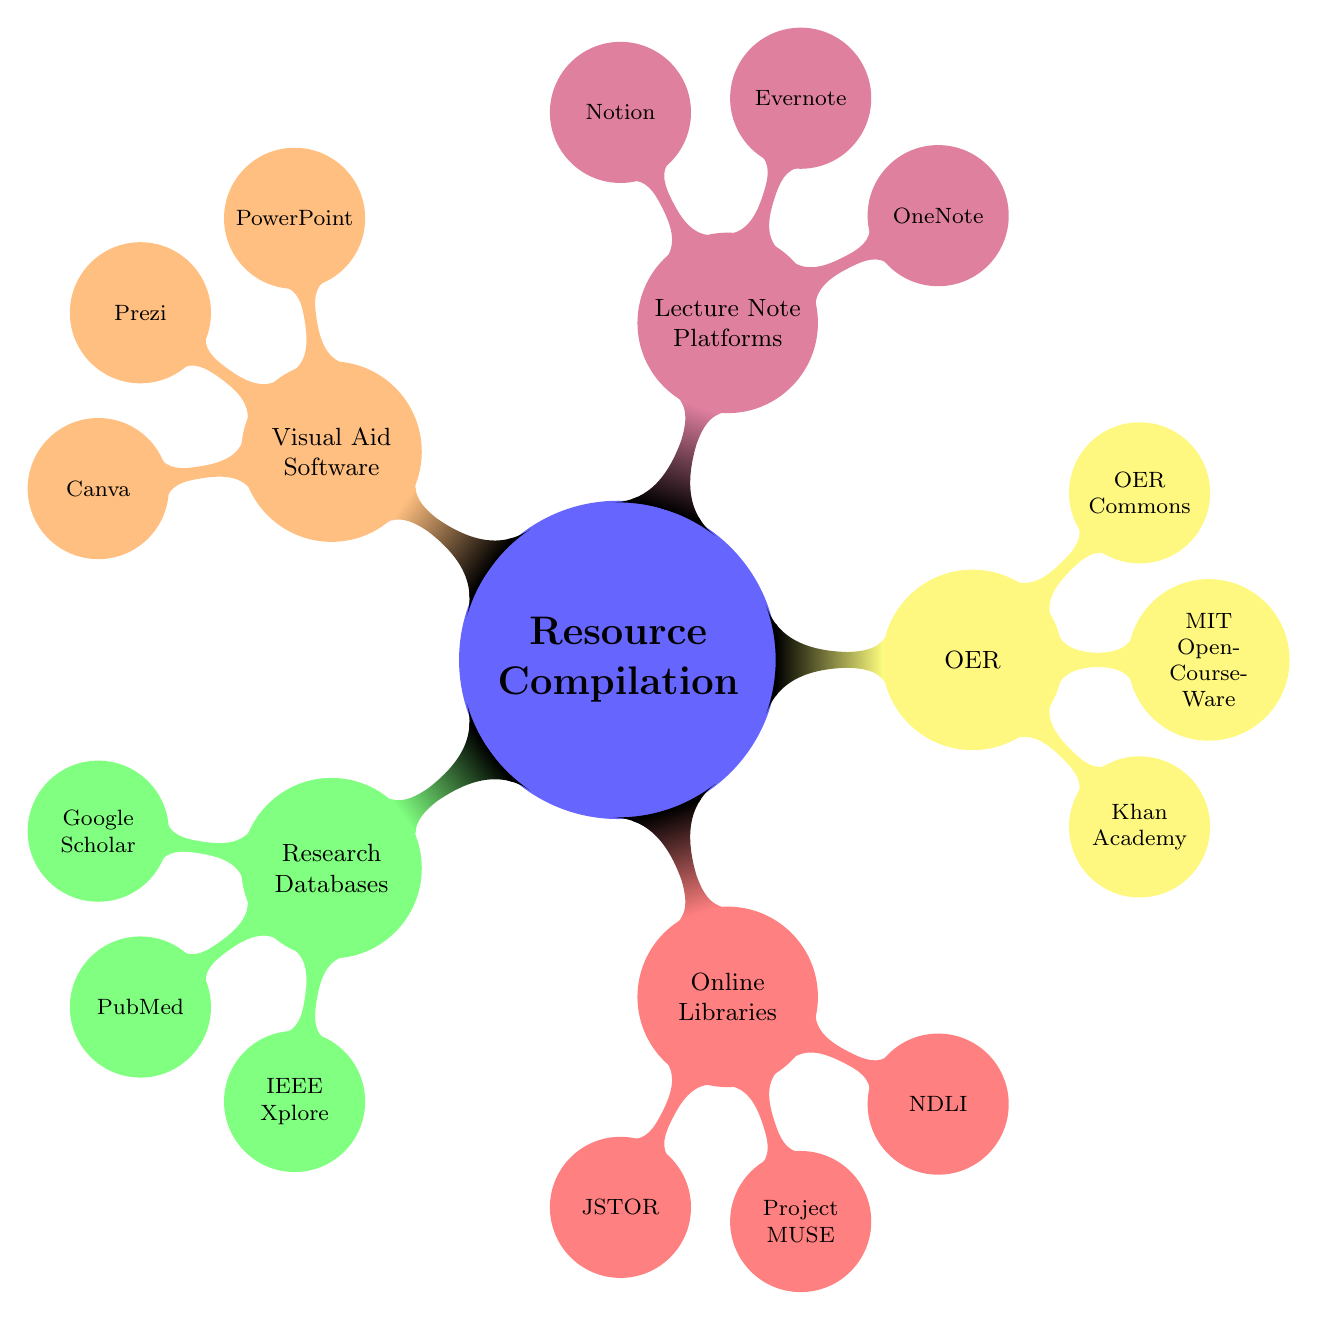What is a resource listed under Research Databases? The question prompts for a specific resource belonging to the "Research Databases" category. Looking at the diagram, the options include Google Scholar, PubMed, and IEEE Xplore. Any of these would be correct.
Answer: Google Scholar How many main categories are there in the mind map? The main categories branch from the central node labeled "Resource Compilation." These categories are "Research Databases," "Online Libraries," "Open Educational Resources," "Lecture Note Platforms," and "Visual Aid Software." Counting those gives us a total of five categories.
Answer: 5 Which platform is known for providing comprehensive educational videos? This question asks for a specific platform associated with educational content in the "Open Educational Resources" section. By examining the nodes under that category, Khan Academy is clearly indicated as providing comprehensive educational videos.
Answer: Khan Academy What type of software is PowerPoint categorized under? The question focuses on the category of "PowerPoint." According to the structure of the mind map, PowerPoint falls under the "Visual Aid Software" category. This connection can be made by noting where PowerPoint is situated in relation to other nodes.
Answer: Visual Aid Software How many resources are listed under Online Libraries? To answer this question, we look into the "Online Libraries" category and count the connected nodes: JSTOR, Project MUSE, and National Digital Library of India, which totals three resources.
Answer: 3 Which category contains the resource MIT OpenCourseWare? This asks for the category that includes "MIT OpenCourseWare." By looking at the placement of MIT OpenCourseWare in the mind map, it is located under the "Open Educational Resources" category, which can be directly identified from the diagram.
Answer: Open Educational Resources Which research database focuses on technical and engineering research? This question requires identifying the specific research database under the "Research Databases" category. On examining the nodes, IEEE Xplore is indeed the database listed that focuses specifically on technical and engineering research.
Answer: IEEE Xplore Which platform is designed for collaborative note-taking? To answer this, we need to identify the platform that is meant for collaborative efforts in note-taking. By reviewing the "Lecture Note Platforms" section, it is clear that OneNote is the platform designed for this purpose.
Answer: OneNote What is the common feature among the resources in the Open Educational Resources category? This question asks for a feature that applies to all resources in the "Open Educational Resources" category. Noting these resources (Khan Academy, MIT OpenCourseWare, OER Commons), they are all openly licensed educational materials which can be reused or modified.
Answer: Openly licensed educational materials 